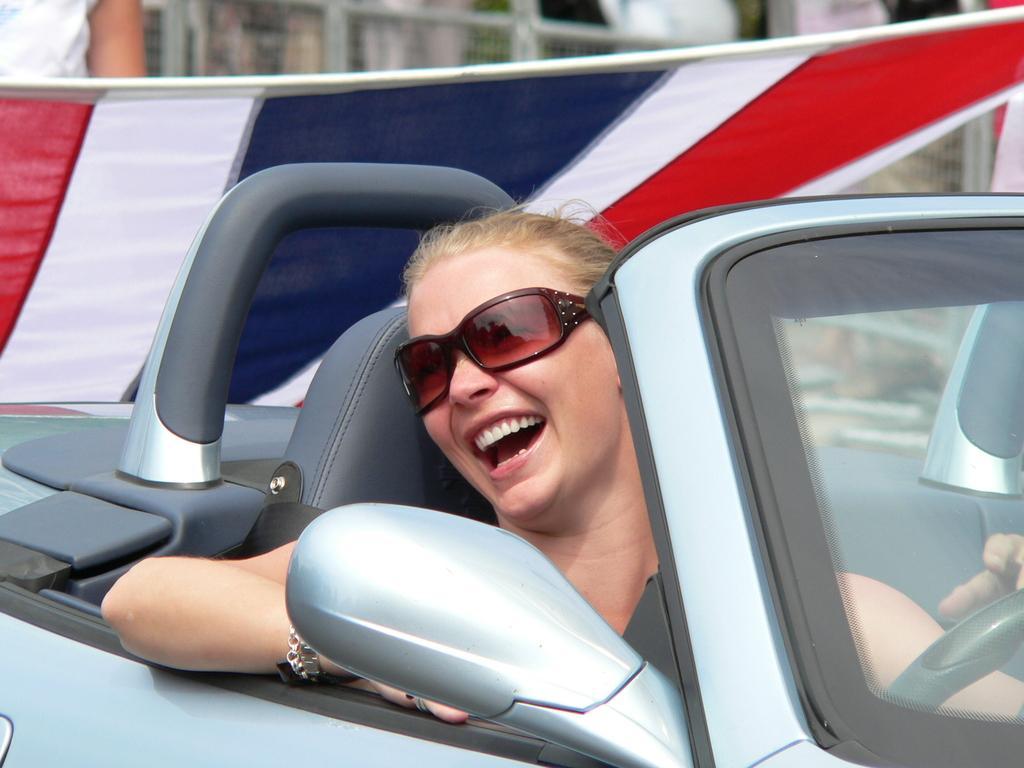Can you describe this image briefly? In this image the woman is riding a car,wearing goggles. The woman is smiling. At the background there is a fencing and a flag. 